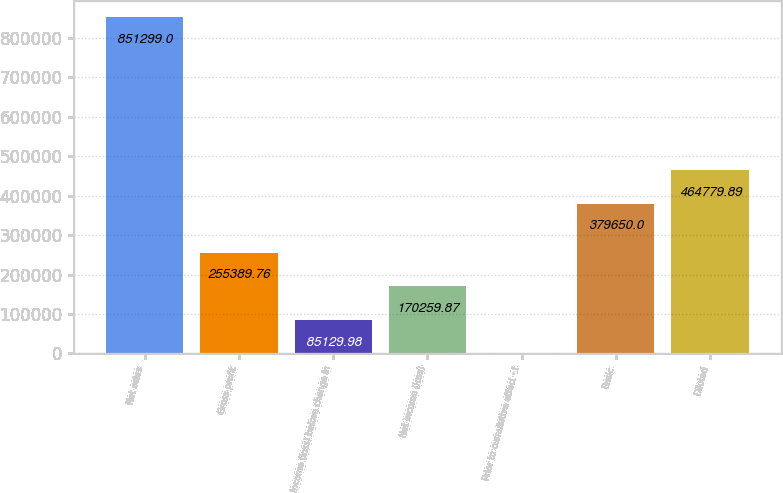Convert chart. <chart><loc_0><loc_0><loc_500><loc_500><bar_chart><fcel>Net sales<fcel>Gross profit<fcel>Income (loss) before change in<fcel>Net income (loss)<fcel>Prior to cumulative effect of<fcel>Basic<fcel>Diluted<nl><fcel>851299<fcel>255390<fcel>85130<fcel>170260<fcel>0.09<fcel>379650<fcel>464780<nl></chart> 